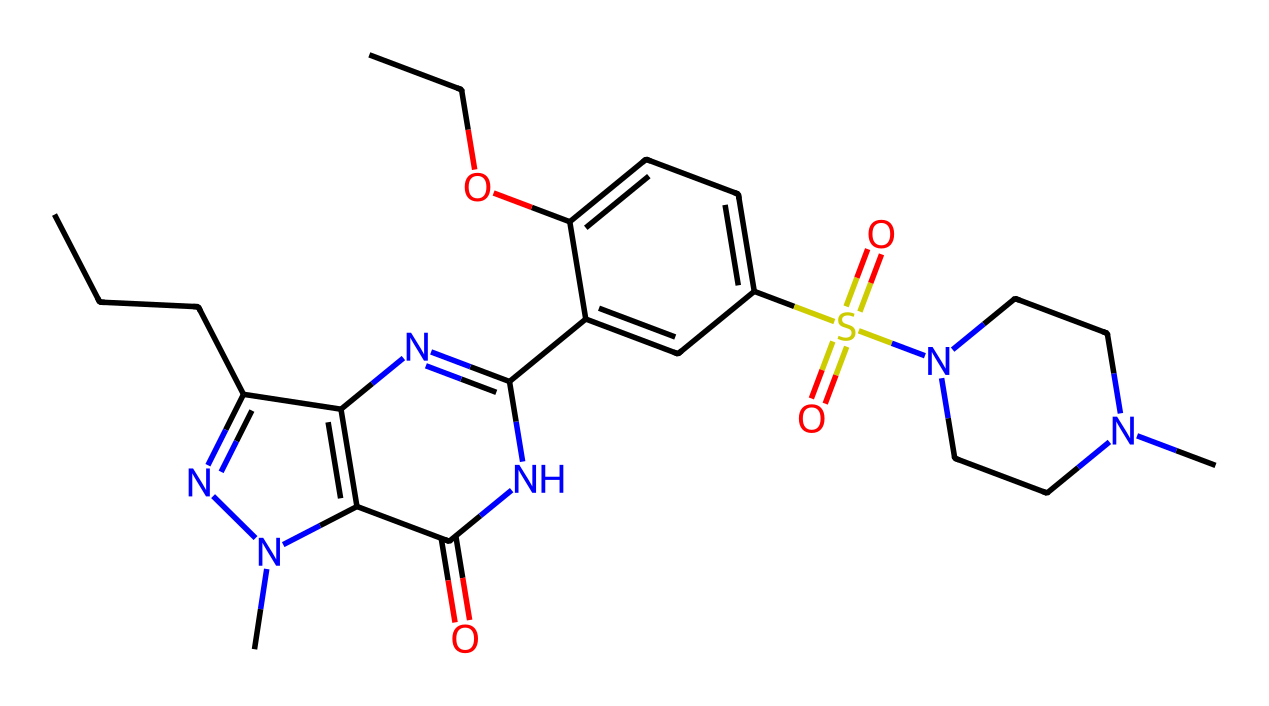What is the main functional group in sildenafil? The main functional group in sildenafil is the sulfonamide group, identified by the presence of the sulfur connected to two oxygen atoms and a nitrogen atom.
Answer: sulfonamide How many carbon atoms are in the sildenafil structure? Counting the carbon atoms in the SMILES representation, there are a total of 20 carbon atoms.
Answer: 20 What is the total number of nitrogen atoms in sildenafil? Upon examining the structure, there are 4 nitrogen atoms present in the sildenafil molecule as indicated in the SMILES representation.
Answer: 4 Which part of the molecule is responsible for its medicinal properties? The aromatic ring system combined with the functional groups such as sulfonamide and the nitrogen atoms contribute to the unique pharmacological activity of sildenafil, enhancing its ability to inhibit phosphodiesterase.
Answer: aromatic ring system What type of drug class does sildenafil belong to? Sildenafil belongs to the class of phosphodiesterase type 5 inhibitors, which is indicated by its chemical actions and structure involving important nitrogen-containing moieties.
Answer: phosphodiesterase type 5 inhibitor 